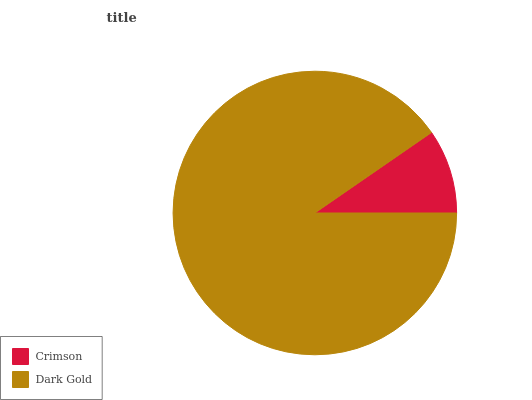Is Crimson the minimum?
Answer yes or no. Yes. Is Dark Gold the maximum?
Answer yes or no. Yes. Is Dark Gold the minimum?
Answer yes or no. No. Is Dark Gold greater than Crimson?
Answer yes or no. Yes. Is Crimson less than Dark Gold?
Answer yes or no. Yes. Is Crimson greater than Dark Gold?
Answer yes or no. No. Is Dark Gold less than Crimson?
Answer yes or no. No. Is Dark Gold the high median?
Answer yes or no. Yes. Is Crimson the low median?
Answer yes or no. Yes. Is Crimson the high median?
Answer yes or no. No. Is Dark Gold the low median?
Answer yes or no. No. 